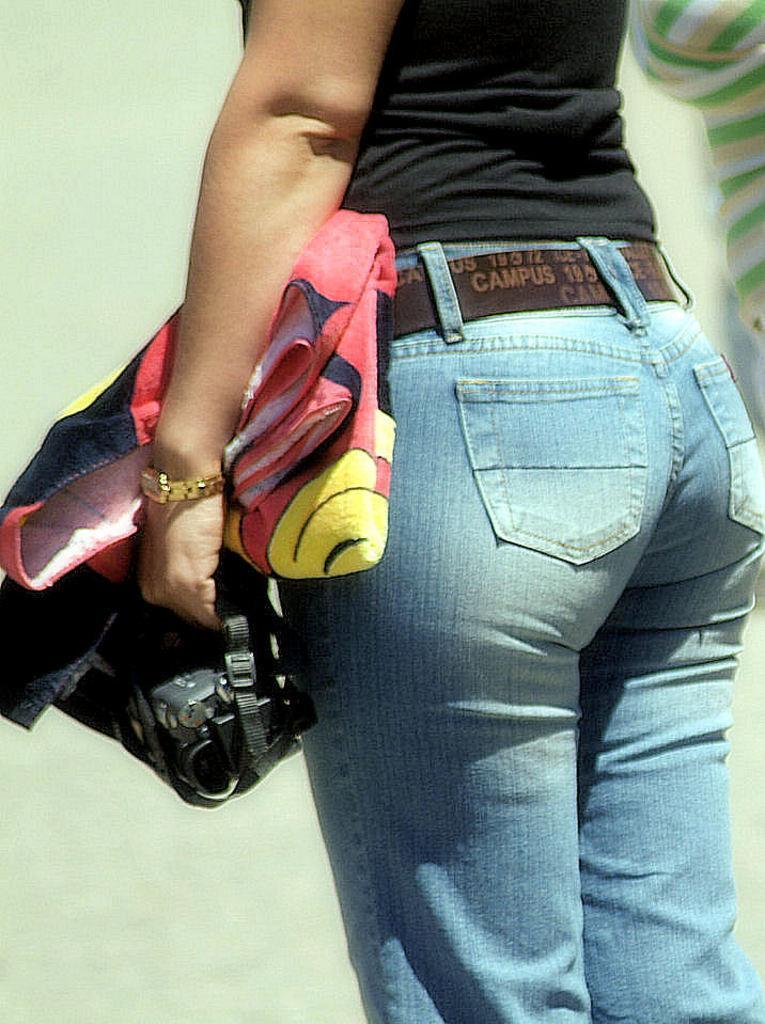Describe this image in one or two sentences. In this image there is a person standing and holding an object and a cloth, beside her there is another person. 